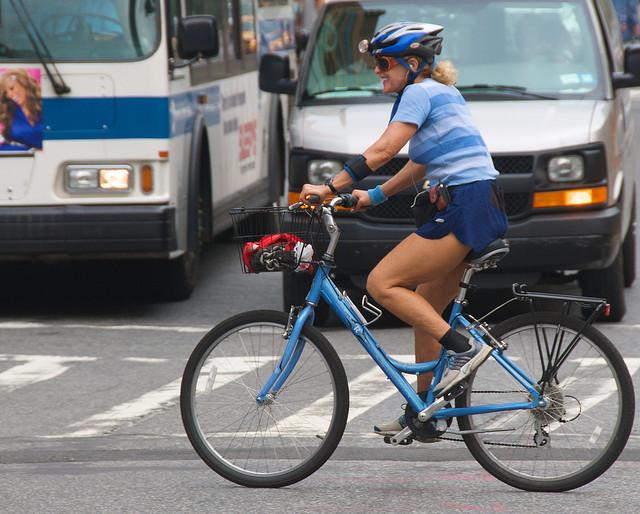What is in her ears?
Be succinct. Headphones. Is she wearing a helmet?
Concise answer only. Yes. Does her bike match her outfit?
Quick response, please. Yes. What color is the stripe on the bus?
Quick response, please. Blue. 